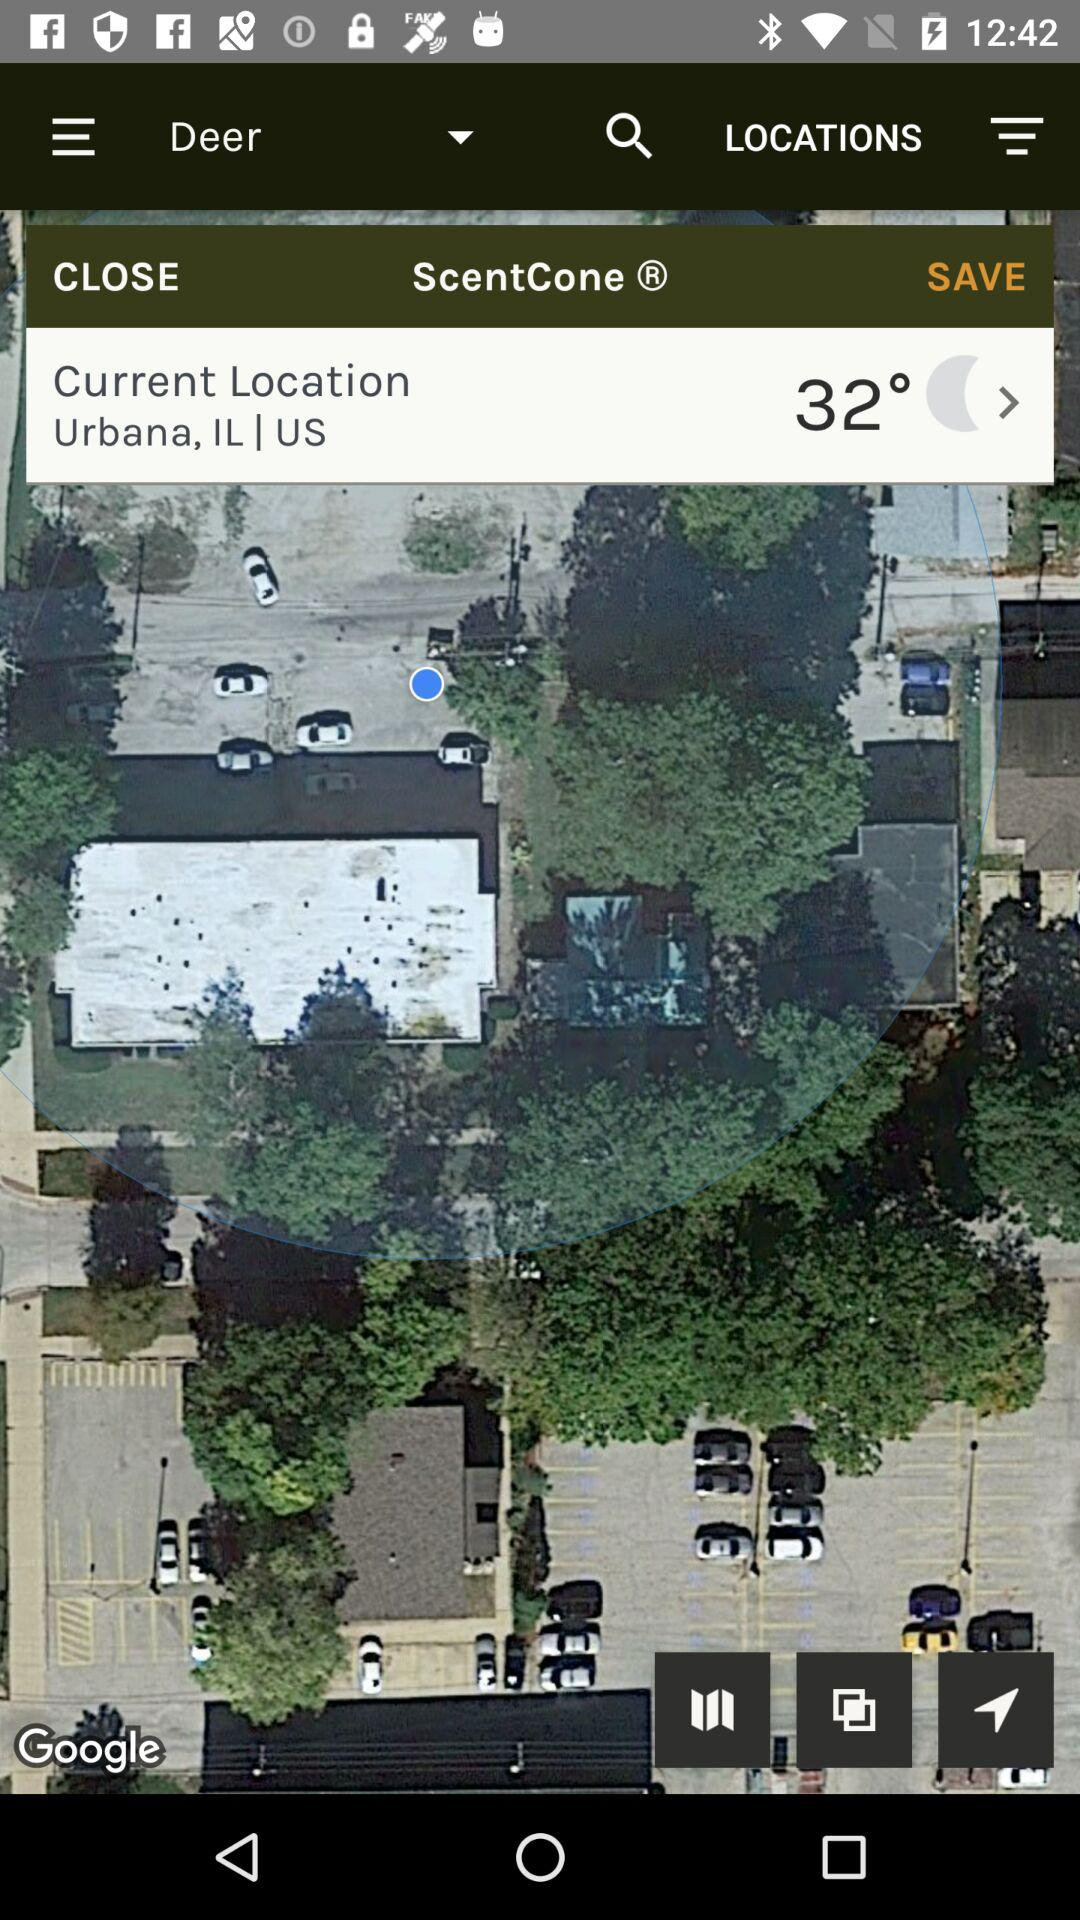What is the current location? The current location is Urbana, IL, US. 